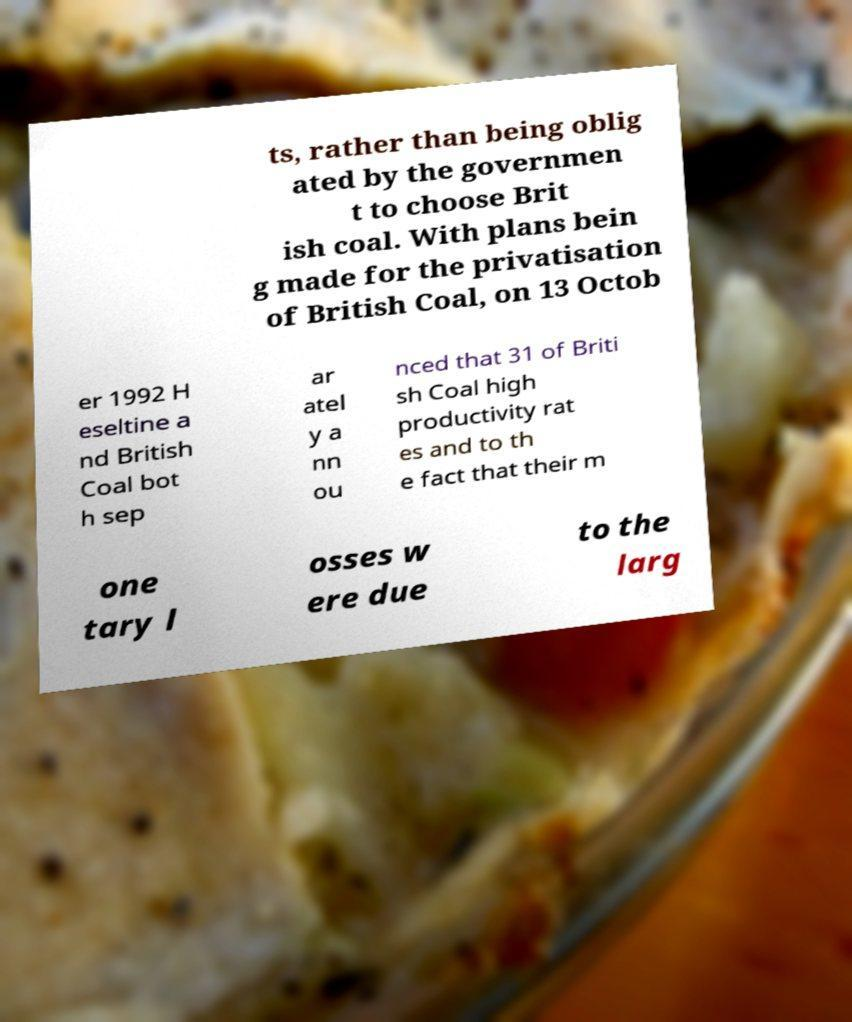I need the written content from this picture converted into text. Can you do that? ts, rather than being oblig ated by the governmen t to choose Brit ish coal. With plans bein g made for the privatisation of British Coal, on 13 Octob er 1992 H eseltine a nd British Coal bot h sep ar atel y a nn ou nced that 31 of Briti sh Coal high productivity rat es and to th e fact that their m one tary l osses w ere due to the larg 